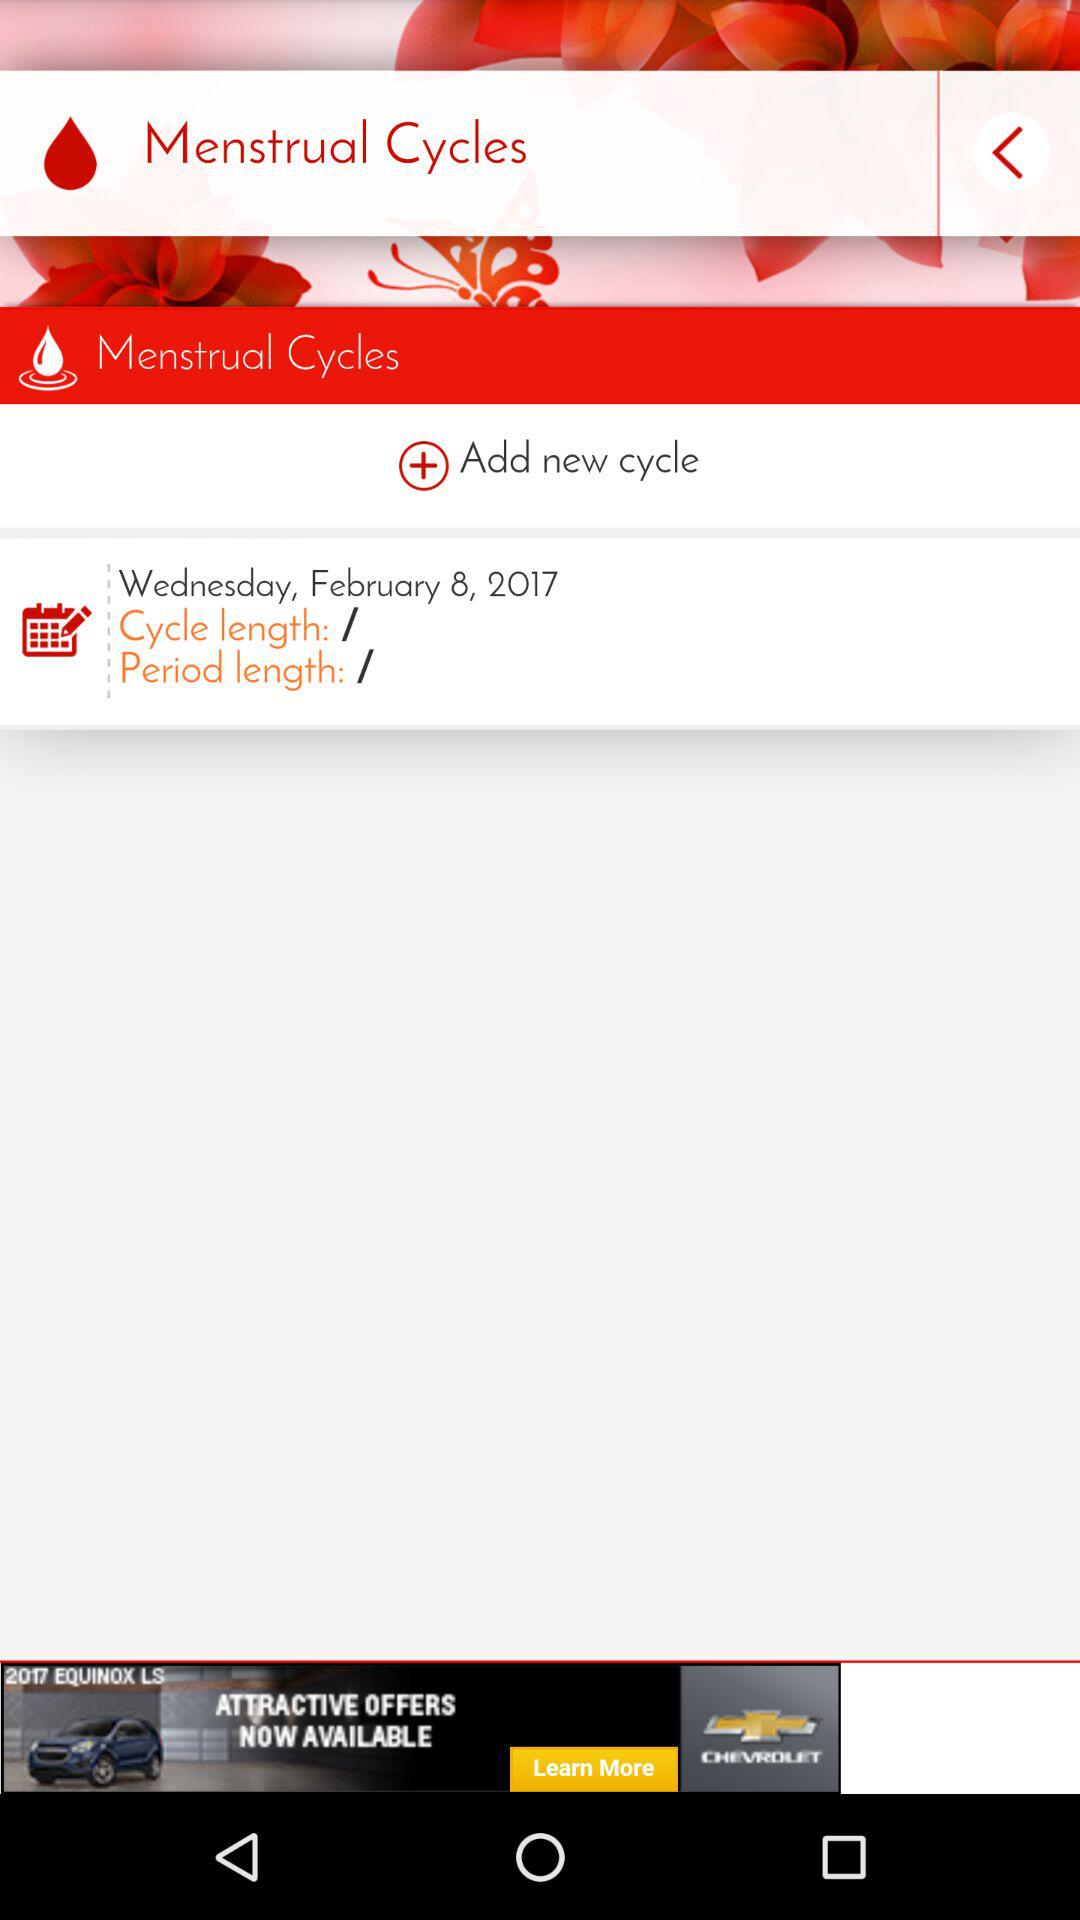What is the day of the upcoming cycle date? The day is Wednesday. 